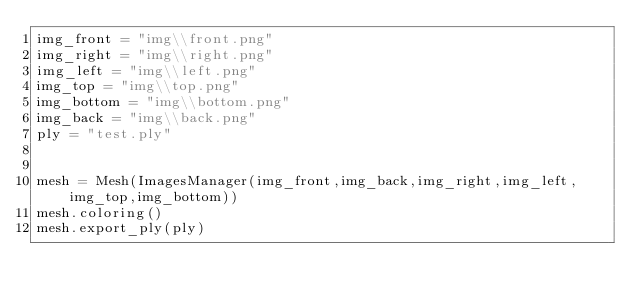<code> <loc_0><loc_0><loc_500><loc_500><_Python_>img_front = "img\\front.png"
img_right = "img\\right.png"
img_left = "img\\left.png"
img_top = "img\\top.png"
img_bottom = "img\\bottom.png"
img_back = "img\\back.png"
ply = "test.ply"


mesh = Mesh(ImagesManager(img_front,img_back,img_right,img_left,img_top,img_bottom))
mesh.coloring()
mesh.export_ply(ply)
</code> 